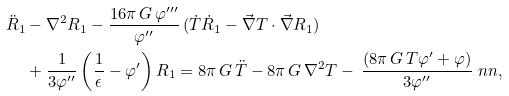<formula> <loc_0><loc_0><loc_500><loc_500>\ddot { R } _ { 1 } & - \nabla ^ { 2 } R _ { 1 } - \frac { 1 6 \pi \, G \, \varphi ^ { \prime \prime \prime } } { \varphi ^ { \prime \prime } } \, ( \dot { T } \dot { R } _ { 1 } - \vec { \nabla } T \cdot \vec { \nabla } R _ { 1 } ) \\ & + \frac { 1 } { 3 \varphi ^ { \prime \prime } } \left ( \frac { 1 } { \epsilon } - \varphi ^ { \prime } \right ) R _ { 1 } = 8 \pi \, G \, \ddot { T } - 8 \pi \, G \, \nabla ^ { 2 } T - \, \frac { \left ( 8 \pi \, G \, T \varphi ^ { \prime } + \varphi \right ) } { 3 \varphi ^ { \prime \prime } } \ n n ,</formula> 